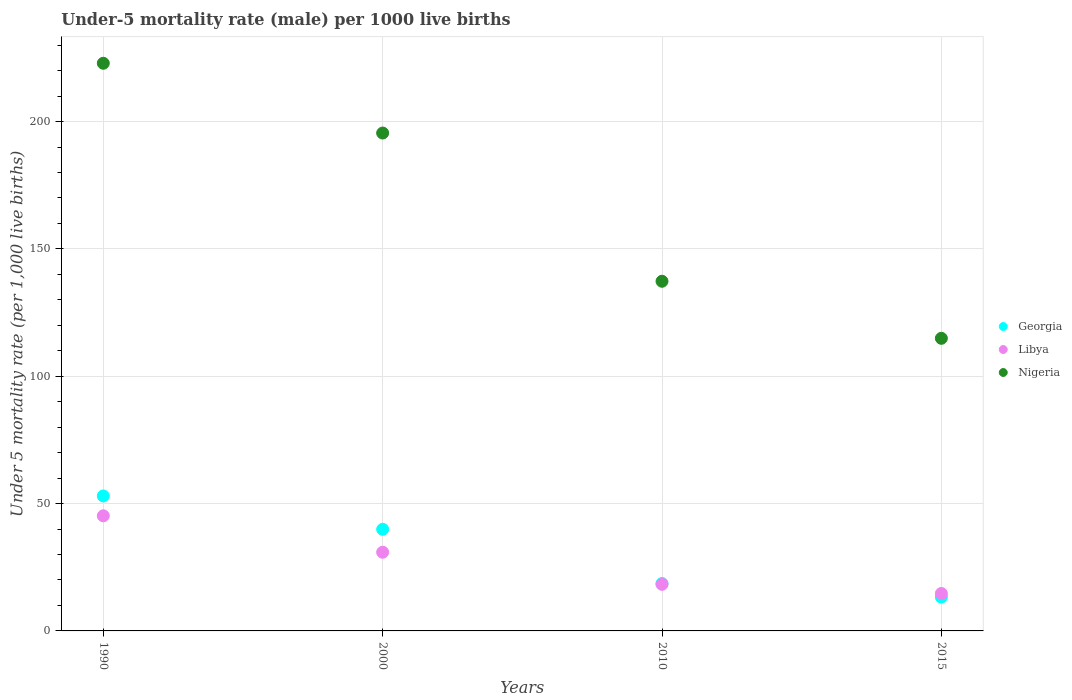Is the number of dotlines equal to the number of legend labels?
Give a very brief answer. Yes. What is the under-five mortality rate in Libya in 2000?
Your answer should be very brief. 30.9. Across all years, what is the maximum under-five mortality rate in Libya?
Give a very brief answer. 45.2. Across all years, what is the minimum under-five mortality rate in Nigeria?
Give a very brief answer. 114.9. In which year was the under-five mortality rate in Nigeria minimum?
Provide a succinct answer. 2015. What is the total under-five mortality rate in Nigeria in the graph?
Offer a terse response. 670.6. What is the difference between the under-five mortality rate in Georgia in 1990 and that in 2000?
Provide a short and direct response. 13.1. What is the difference between the under-five mortality rate in Libya in 2000 and the under-five mortality rate in Georgia in 2010?
Keep it short and to the point. 12.3. What is the average under-five mortality rate in Libya per year?
Your response must be concise. 27.27. In the year 2000, what is the difference between the under-five mortality rate in Nigeria and under-five mortality rate in Libya?
Your response must be concise. 164.6. What is the ratio of the under-five mortality rate in Nigeria in 1990 to that in 2015?
Ensure brevity in your answer.  1.94. Is the difference between the under-five mortality rate in Nigeria in 1990 and 2015 greater than the difference between the under-five mortality rate in Libya in 1990 and 2015?
Your answer should be very brief. Yes. What is the difference between the highest and the second highest under-five mortality rate in Georgia?
Provide a succinct answer. 13.1. What is the difference between the highest and the lowest under-five mortality rate in Georgia?
Your answer should be compact. 39.7. Is the sum of the under-five mortality rate in Georgia in 2000 and 2010 greater than the maximum under-five mortality rate in Nigeria across all years?
Give a very brief answer. No. Is it the case that in every year, the sum of the under-five mortality rate in Nigeria and under-five mortality rate in Libya  is greater than the under-five mortality rate in Georgia?
Ensure brevity in your answer.  Yes. Does the under-five mortality rate in Georgia monotonically increase over the years?
Provide a succinct answer. No. Is the under-five mortality rate in Georgia strictly greater than the under-five mortality rate in Nigeria over the years?
Your answer should be very brief. No. Is the under-five mortality rate in Georgia strictly less than the under-five mortality rate in Libya over the years?
Your answer should be compact. No. Are the values on the major ticks of Y-axis written in scientific E-notation?
Give a very brief answer. No. Does the graph contain any zero values?
Keep it short and to the point. No. Where does the legend appear in the graph?
Your response must be concise. Center right. How many legend labels are there?
Provide a succinct answer. 3. What is the title of the graph?
Ensure brevity in your answer.  Under-5 mortality rate (male) per 1000 live births. What is the label or title of the Y-axis?
Your answer should be very brief. Under 5 mortality rate (per 1,0 live births). What is the Under 5 mortality rate (per 1,000 live births) of Georgia in 1990?
Make the answer very short. 53. What is the Under 5 mortality rate (per 1,000 live births) of Libya in 1990?
Offer a very short reply. 45.2. What is the Under 5 mortality rate (per 1,000 live births) of Nigeria in 1990?
Give a very brief answer. 222.9. What is the Under 5 mortality rate (per 1,000 live births) of Georgia in 2000?
Your response must be concise. 39.9. What is the Under 5 mortality rate (per 1,000 live births) in Libya in 2000?
Offer a very short reply. 30.9. What is the Under 5 mortality rate (per 1,000 live births) of Nigeria in 2000?
Your answer should be compact. 195.5. What is the Under 5 mortality rate (per 1,000 live births) of Libya in 2010?
Keep it short and to the point. 18.3. What is the Under 5 mortality rate (per 1,000 live births) in Nigeria in 2010?
Offer a very short reply. 137.3. What is the Under 5 mortality rate (per 1,000 live births) in Georgia in 2015?
Keep it short and to the point. 13.3. What is the Under 5 mortality rate (per 1,000 live births) in Nigeria in 2015?
Provide a short and direct response. 114.9. Across all years, what is the maximum Under 5 mortality rate (per 1,000 live births) of Libya?
Make the answer very short. 45.2. Across all years, what is the maximum Under 5 mortality rate (per 1,000 live births) in Nigeria?
Your answer should be very brief. 222.9. Across all years, what is the minimum Under 5 mortality rate (per 1,000 live births) in Nigeria?
Your response must be concise. 114.9. What is the total Under 5 mortality rate (per 1,000 live births) of Georgia in the graph?
Make the answer very short. 124.8. What is the total Under 5 mortality rate (per 1,000 live births) in Libya in the graph?
Your response must be concise. 109.1. What is the total Under 5 mortality rate (per 1,000 live births) of Nigeria in the graph?
Your answer should be very brief. 670.6. What is the difference between the Under 5 mortality rate (per 1,000 live births) in Libya in 1990 and that in 2000?
Your answer should be very brief. 14.3. What is the difference between the Under 5 mortality rate (per 1,000 live births) in Nigeria in 1990 and that in 2000?
Your answer should be compact. 27.4. What is the difference between the Under 5 mortality rate (per 1,000 live births) in Georgia in 1990 and that in 2010?
Offer a very short reply. 34.4. What is the difference between the Under 5 mortality rate (per 1,000 live births) in Libya in 1990 and that in 2010?
Offer a terse response. 26.9. What is the difference between the Under 5 mortality rate (per 1,000 live births) of Nigeria in 1990 and that in 2010?
Offer a very short reply. 85.6. What is the difference between the Under 5 mortality rate (per 1,000 live births) of Georgia in 1990 and that in 2015?
Offer a terse response. 39.7. What is the difference between the Under 5 mortality rate (per 1,000 live births) of Libya in 1990 and that in 2015?
Provide a short and direct response. 30.5. What is the difference between the Under 5 mortality rate (per 1,000 live births) in Nigeria in 1990 and that in 2015?
Provide a short and direct response. 108. What is the difference between the Under 5 mortality rate (per 1,000 live births) in Georgia in 2000 and that in 2010?
Offer a terse response. 21.3. What is the difference between the Under 5 mortality rate (per 1,000 live births) of Libya in 2000 and that in 2010?
Your answer should be compact. 12.6. What is the difference between the Under 5 mortality rate (per 1,000 live births) of Nigeria in 2000 and that in 2010?
Keep it short and to the point. 58.2. What is the difference between the Under 5 mortality rate (per 1,000 live births) in Georgia in 2000 and that in 2015?
Ensure brevity in your answer.  26.6. What is the difference between the Under 5 mortality rate (per 1,000 live births) of Libya in 2000 and that in 2015?
Keep it short and to the point. 16.2. What is the difference between the Under 5 mortality rate (per 1,000 live births) of Nigeria in 2000 and that in 2015?
Make the answer very short. 80.6. What is the difference between the Under 5 mortality rate (per 1,000 live births) of Libya in 2010 and that in 2015?
Make the answer very short. 3.6. What is the difference between the Under 5 mortality rate (per 1,000 live births) of Nigeria in 2010 and that in 2015?
Offer a terse response. 22.4. What is the difference between the Under 5 mortality rate (per 1,000 live births) in Georgia in 1990 and the Under 5 mortality rate (per 1,000 live births) in Libya in 2000?
Keep it short and to the point. 22.1. What is the difference between the Under 5 mortality rate (per 1,000 live births) of Georgia in 1990 and the Under 5 mortality rate (per 1,000 live births) of Nigeria in 2000?
Make the answer very short. -142.5. What is the difference between the Under 5 mortality rate (per 1,000 live births) in Libya in 1990 and the Under 5 mortality rate (per 1,000 live births) in Nigeria in 2000?
Your answer should be very brief. -150.3. What is the difference between the Under 5 mortality rate (per 1,000 live births) of Georgia in 1990 and the Under 5 mortality rate (per 1,000 live births) of Libya in 2010?
Provide a succinct answer. 34.7. What is the difference between the Under 5 mortality rate (per 1,000 live births) in Georgia in 1990 and the Under 5 mortality rate (per 1,000 live births) in Nigeria in 2010?
Your answer should be compact. -84.3. What is the difference between the Under 5 mortality rate (per 1,000 live births) in Libya in 1990 and the Under 5 mortality rate (per 1,000 live births) in Nigeria in 2010?
Offer a terse response. -92.1. What is the difference between the Under 5 mortality rate (per 1,000 live births) in Georgia in 1990 and the Under 5 mortality rate (per 1,000 live births) in Libya in 2015?
Your answer should be compact. 38.3. What is the difference between the Under 5 mortality rate (per 1,000 live births) in Georgia in 1990 and the Under 5 mortality rate (per 1,000 live births) in Nigeria in 2015?
Your response must be concise. -61.9. What is the difference between the Under 5 mortality rate (per 1,000 live births) in Libya in 1990 and the Under 5 mortality rate (per 1,000 live births) in Nigeria in 2015?
Ensure brevity in your answer.  -69.7. What is the difference between the Under 5 mortality rate (per 1,000 live births) of Georgia in 2000 and the Under 5 mortality rate (per 1,000 live births) of Libya in 2010?
Offer a very short reply. 21.6. What is the difference between the Under 5 mortality rate (per 1,000 live births) of Georgia in 2000 and the Under 5 mortality rate (per 1,000 live births) of Nigeria in 2010?
Your response must be concise. -97.4. What is the difference between the Under 5 mortality rate (per 1,000 live births) of Libya in 2000 and the Under 5 mortality rate (per 1,000 live births) of Nigeria in 2010?
Make the answer very short. -106.4. What is the difference between the Under 5 mortality rate (per 1,000 live births) of Georgia in 2000 and the Under 5 mortality rate (per 1,000 live births) of Libya in 2015?
Make the answer very short. 25.2. What is the difference between the Under 5 mortality rate (per 1,000 live births) in Georgia in 2000 and the Under 5 mortality rate (per 1,000 live births) in Nigeria in 2015?
Your answer should be very brief. -75. What is the difference between the Under 5 mortality rate (per 1,000 live births) in Libya in 2000 and the Under 5 mortality rate (per 1,000 live births) in Nigeria in 2015?
Provide a short and direct response. -84. What is the difference between the Under 5 mortality rate (per 1,000 live births) of Georgia in 2010 and the Under 5 mortality rate (per 1,000 live births) of Nigeria in 2015?
Make the answer very short. -96.3. What is the difference between the Under 5 mortality rate (per 1,000 live births) in Libya in 2010 and the Under 5 mortality rate (per 1,000 live births) in Nigeria in 2015?
Your answer should be compact. -96.6. What is the average Under 5 mortality rate (per 1,000 live births) of Georgia per year?
Make the answer very short. 31.2. What is the average Under 5 mortality rate (per 1,000 live births) of Libya per year?
Give a very brief answer. 27.27. What is the average Under 5 mortality rate (per 1,000 live births) of Nigeria per year?
Your answer should be compact. 167.65. In the year 1990, what is the difference between the Under 5 mortality rate (per 1,000 live births) of Georgia and Under 5 mortality rate (per 1,000 live births) of Nigeria?
Make the answer very short. -169.9. In the year 1990, what is the difference between the Under 5 mortality rate (per 1,000 live births) in Libya and Under 5 mortality rate (per 1,000 live births) in Nigeria?
Keep it short and to the point. -177.7. In the year 2000, what is the difference between the Under 5 mortality rate (per 1,000 live births) in Georgia and Under 5 mortality rate (per 1,000 live births) in Nigeria?
Provide a short and direct response. -155.6. In the year 2000, what is the difference between the Under 5 mortality rate (per 1,000 live births) of Libya and Under 5 mortality rate (per 1,000 live births) of Nigeria?
Offer a terse response. -164.6. In the year 2010, what is the difference between the Under 5 mortality rate (per 1,000 live births) of Georgia and Under 5 mortality rate (per 1,000 live births) of Libya?
Keep it short and to the point. 0.3. In the year 2010, what is the difference between the Under 5 mortality rate (per 1,000 live births) of Georgia and Under 5 mortality rate (per 1,000 live births) of Nigeria?
Keep it short and to the point. -118.7. In the year 2010, what is the difference between the Under 5 mortality rate (per 1,000 live births) of Libya and Under 5 mortality rate (per 1,000 live births) of Nigeria?
Your response must be concise. -119. In the year 2015, what is the difference between the Under 5 mortality rate (per 1,000 live births) in Georgia and Under 5 mortality rate (per 1,000 live births) in Nigeria?
Offer a terse response. -101.6. In the year 2015, what is the difference between the Under 5 mortality rate (per 1,000 live births) of Libya and Under 5 mortality rate (per 1,000 live births) of Nigeria?
Provide a short and direct response. -100.2. What is the ratio of the Under 5 mortality rate (per 1,000 live births) in Georgia in 1990 to that in 2000?
Offer a very short reply. 1.33. What is the ratio of the Under 5 mortality rate (per 1,000 live births) in Libya in 1990 to that in 2000?
Offer a very short reply. 1.46. What is the ratio of the Under 5 mortality rate (per 1,000 live births) in Nigeria in 1990 to that in 2000?
Provide a succinct answer. 1.14. What is the ratio of the Under 5 mortality rate (per 1,000 live births) in Georgia in 1990 to that in 2010?
Provide a short and direct response. 2.85. What is the ratio of the Under 5 mortality rate (per 1,000 live births) in Libya in 1990 to that in 2010?
Make the answer very short. 2.47. What is the ratio of the Under 5 mortality rate (per 1,000 live births) of Nigeria in 1990 to that in 2010?
Give a very brief answer. 1.62. What is the ratio of the Under 5 mortality rate (per 1,000 live births) of Georgia in 1990 to that in 2015?
Provide a succinct answer. 3.98. What is the ratio of the Under 5 mortality rate (per 1,000 live births) of Libya in 1990 to that in 2015?
Your answer should be compact. 3.07. What is the ratio of the Under 5 mortality rate (per 1,000 live births) in Nigeria in 1990 to that in 2015?
Ensure brevity in your answer.  1.94. What is the ratio of the Under 5 mortality rate (per 1,000 live births) in Georgia in 2000 to that in 2010?
Provide a short and direct response. 2.15. What is the ratio of the Under 5 mortality rate (per 1,000 live births) in Libya in 2000 to that in 2010?
Offer a very short reply. 1.69. What is the ratio of the Under 5 mortality rate (per 1,000 live births) of Nigeria in 2000 to that in 2010?
Give a very brief answer. 1.42. What is the ratio of the Under 5 mortality rate (per 1,000 live births) of Libya in 2000 to that in 2015?
Provide a succinct answer. 2.1. What is the ratio of the Under 5 mortality rate (per 1,000 live births) of Nigeria in 2000 to that in 2015?
Ensure brevity in your answer.  1.7. What is the ratio of the Under 5 mortality rate (per 1,000 live births) of Georgia in 2010 to that in 2015?
Offer a very short reply. 1.4. What is the ratio of the Under 5 mortality rate (per 1,000 live births) in Libya in 2010 to that in 2015?
Your response must be concise. 1.24. What is the ratio of the Under 5 mortality rate (per 1,000 live births) in Nigeria in 2010 to that in 2015?
Give a very brief answer. 1.2. What is the difference between the highest and the second highest Under 5 mortality rate (per 1,000 live births) in Georgia?
Give a very brief answer. 13.1. What is the difference between the highest and the second highest Under 5 mortality rate (per 1,000 live births) in Nigeria?
Your answer should be compact. 27.4. What is the difference between the highest and the lowest Under 5 mortality rate (per 1,000 live births) of Georgia?
Keep it short and to the point. 39.7. What is the difference between the highest and the lowest Under 5 mortality rate (per 1,000 live births) of Libya?
Your answer should be very brief. 30.5. What is the difference between the highest and the lowest Under 5 mortality rate (per 1,000 live births) in Nigeria?
Offer a terse response. 108. 